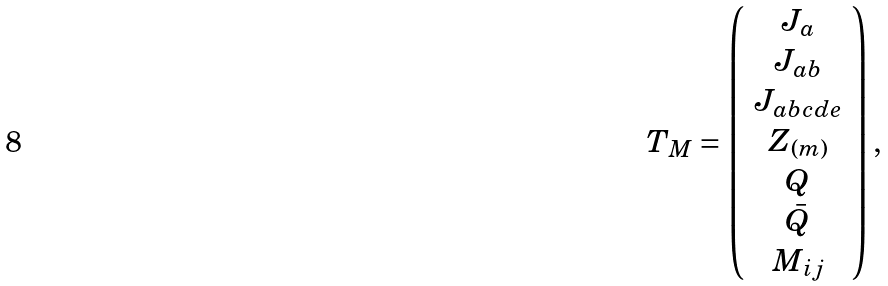<formula> <loc_0><loc_0><loc_500><loc_500>T _ { M } = \left ( \begin{array} { c } J _ { a } \\ J _ { a b } \\ J _ { a b c d e } \\ Z _ { ( m ) } \\ Q \\ \bar { Q } \\ M _ { i j } \end{array} \right ) ,</formula> 